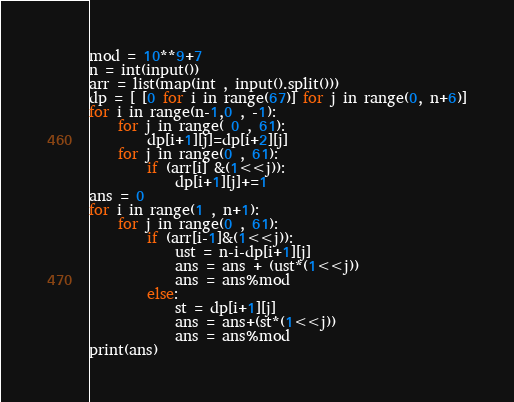<code> <loc_0><loc_0><loc_500><loc_500><_Python_>
mod = 10**9+7
n = int(input())
arr = list(map(int , input().split()))
dp = [ [0 for i in range(67)] for j in range(0, n+6)]
for i in range(n-1,0 , -1):
	for j in range( 0 , 61):
		dp[i+1][j]=dp[i+2][j]
	for j in range(0 , 61):
		if (arr[i] &(1<<j)):
			dp[i+1][j]+=1
ans = 0
for i in range(1 , n+1):
	for j in range(0 , 61):
		if (arr[i-1]&(1<<j)):
			ust = n-i-dp[i+1][j]
			ans = ans + (ust*(1<<j))
			ans = ans%mod
		else:
			st = dp[i+1][j]
			ans = ans+(st*(1<<j))
			ans = ans%mod
print(ans)</code> 